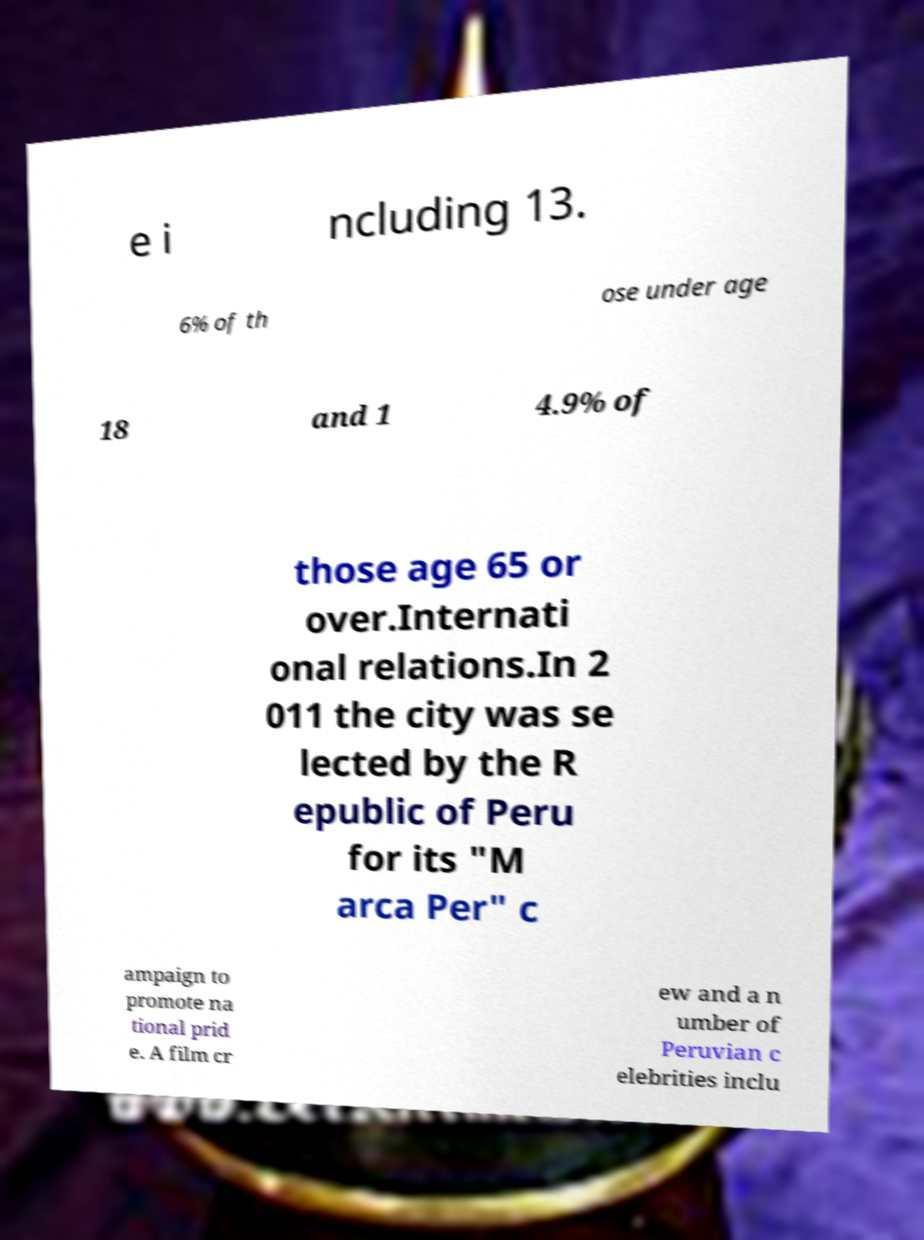Can you read and provide the text displayed in the image?This photo seems to have some interesting text. Can you extract and type it out for me? e i ncluding 13. 6% of th ose under age 18 and 1 4.9% of those age 65 or over.Internati onal relations.In 2 011 the city was se lected by the R epublic of Peru for its "M arca Per" c ampaign to promote na tional prid e. A film cr ew and a n umber of Peruvian c elebrities inclu 